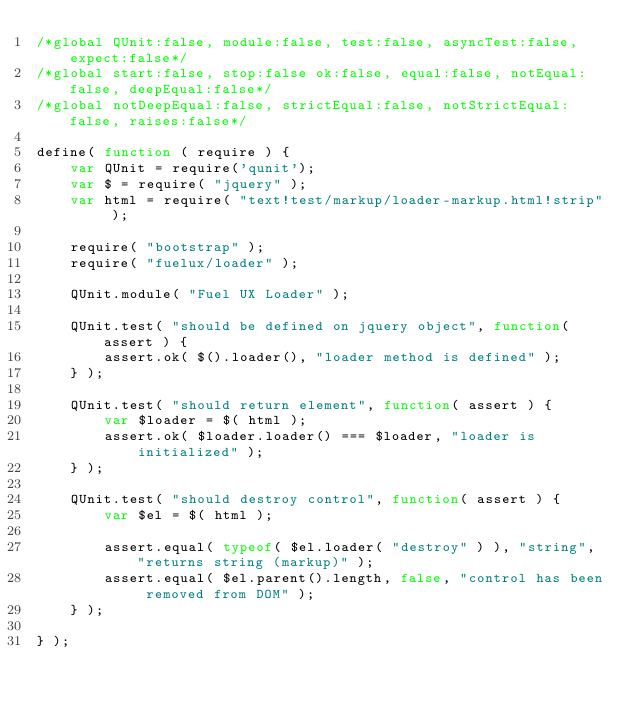Convert code to text. <code><loc_0><loc_0><loc_500><loc_500><_JavaScript_>/*global QUnit:false, module:false, test:false, asyncTest:false, expect:false*/
/*global start:false, stop:false ok:false, equal:false, notEqual:false, deepEqual:false*/
/*global notDeepEqual:false, strictEqual:false, notStrictEqual:false, raises:false*/

define( function ( require ) {
	var QUnit = require('qunit');
	var $ = require( "jquery" );
	var html = require( "text!test/markup/loader-markup.html!strip" );

	require( "bootstrap" );
	require( "fuelux/loader" );

	QUnit.module( "Fuel UX Loader" );

	QUnit.test( "should be defined on jquery object", function( assert ) {
		assert.ok( $().loader(), "loader method is defined" );
	} );

	QUnit.test( "should return element", function( assert ) {
		var $loader = $( html );
		assert.ok( $loader.loader() === $loader, "loader is initialized" );
	} );

	QUnit.test( "should destroy control", function( assert ) {
		var $el = $( html );

		assert.equal( typeof( $el.loader( "destroy" ) ), "string", "returns string (markup)" );
		assert.equal( $el.parent().length, false, "control has been removed from DOM" );
	} );

} );
</code> 